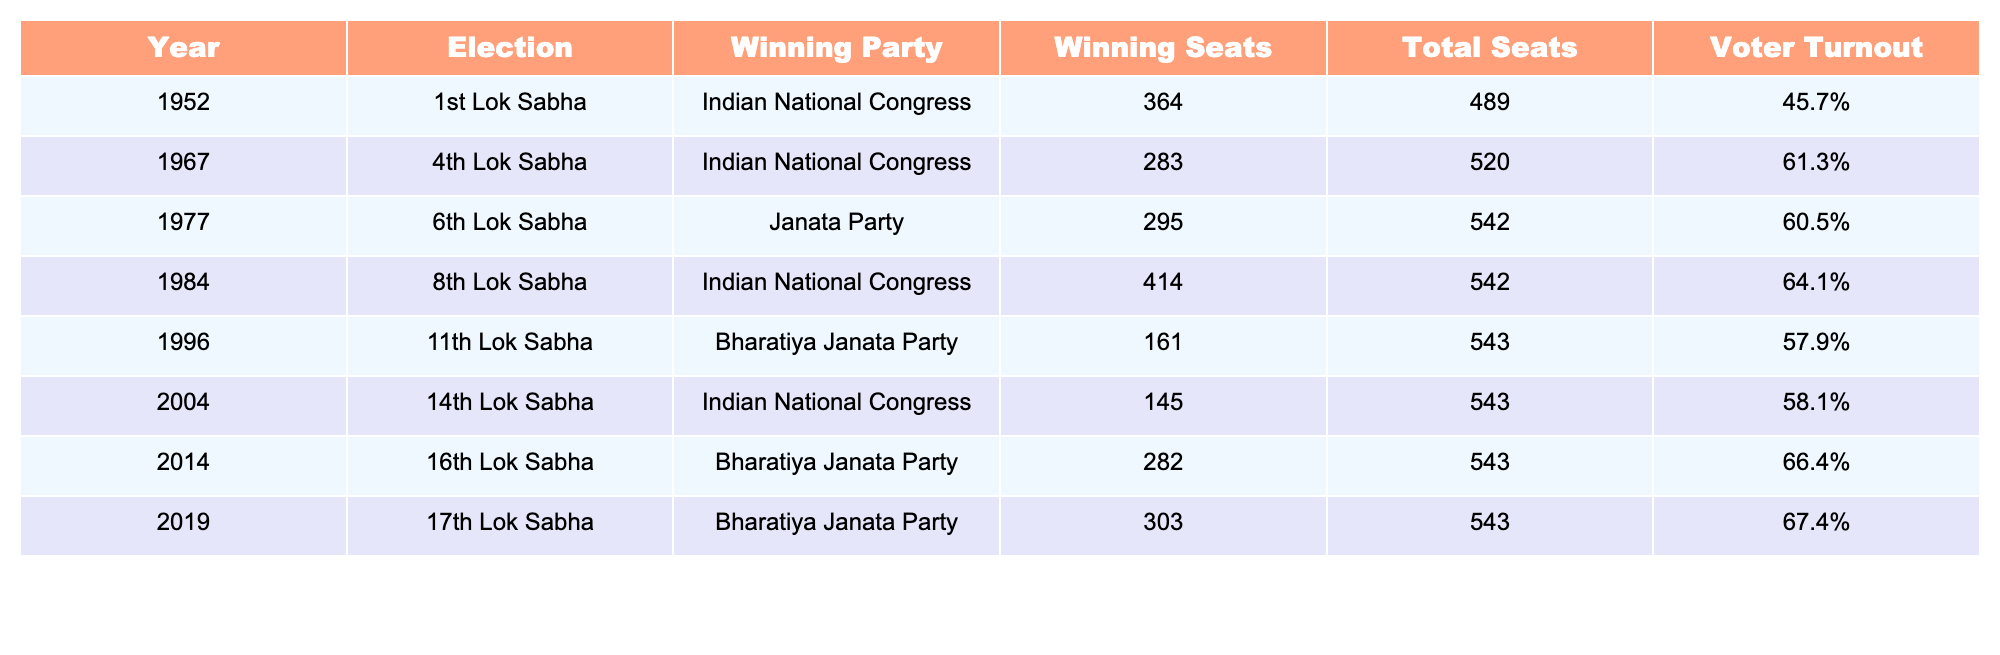What was the voter turnout in the 1984 election? The table lists the voter turnout for each election. For the 1984 election listed in the table, the voter turnout is shown as 64.1%.
Answer: 64.1% Which party won the most seats in the 1st Lok Sabha election? Referring to the 1st Lok Sabha column for the year 1952 in the table, the Indian National Congress is recorded as the winning party with 364 seats.
Answer: Indian National Congress How many total seats were contested in the 16th Lok Sabha election? The table indicates that the total seats for the 16th Lok Sabha election in 2014 were 543. This information is directly listed in the row for that election.
Answer: 543 What is the difference in voter turnout between the 1967 and 1977 elections? The voter turnout for the 1967 election is 61.3% and for the 1977 election it is 60.5%. To find the difference, we subtract 60.5% from 61.3%, resulting in a difference of 0.8%.
Answer: 0.8% Did the Bharatiya Janata Party ever win a majority in the Lok Sabha according to the data? By checking the winning seats for Bharatiya Janata Party in the elections listed, we can see they won 161 (1996), 282 (2014), and 303 (2019). They only had a majority in the 2014 (282 seats) and 2019 (303 seats) elections. Hence, the answer is yes.
Answer: Yes What was the average number of seats won by the Indian National Congress across the elections listed? The seats won by the Indian National Congress in the elections listed are 364 (1952) + 283 (1967) + 414 (1984) + 145 (2004) = 1206. There are 4 elections, so calculating the average involves dividing the total by 4: 1206 / 4 = 301.5.
Answer: 301.5 Which election had the highest voter turnout? By examining the voter turnout percentages listed, the highest value is 67.4% for the 17th Lok Sabha election in 2019, making it the election with the highest turnout.
Answer: 67.4% What was the winning party for the 11th Lok Sabha election? The table indicates that the winning party for the 11th Lok Sabha election in 1996 was the Bharatiya Janata Party. This information is available directly in the table.
Answer: Bharatiya Janata Party How many more seats did the Indian National Congress win in the 8th Lok Sabha compared to the 14th Lok Sabha? The Indian National Congress won 414 seats in the 8th Lok Sabha (1984) and 145 seats in the 14th Lok Sabha (2004). The difference is calculated as 414 - 145 = 269.
Answer: 269 